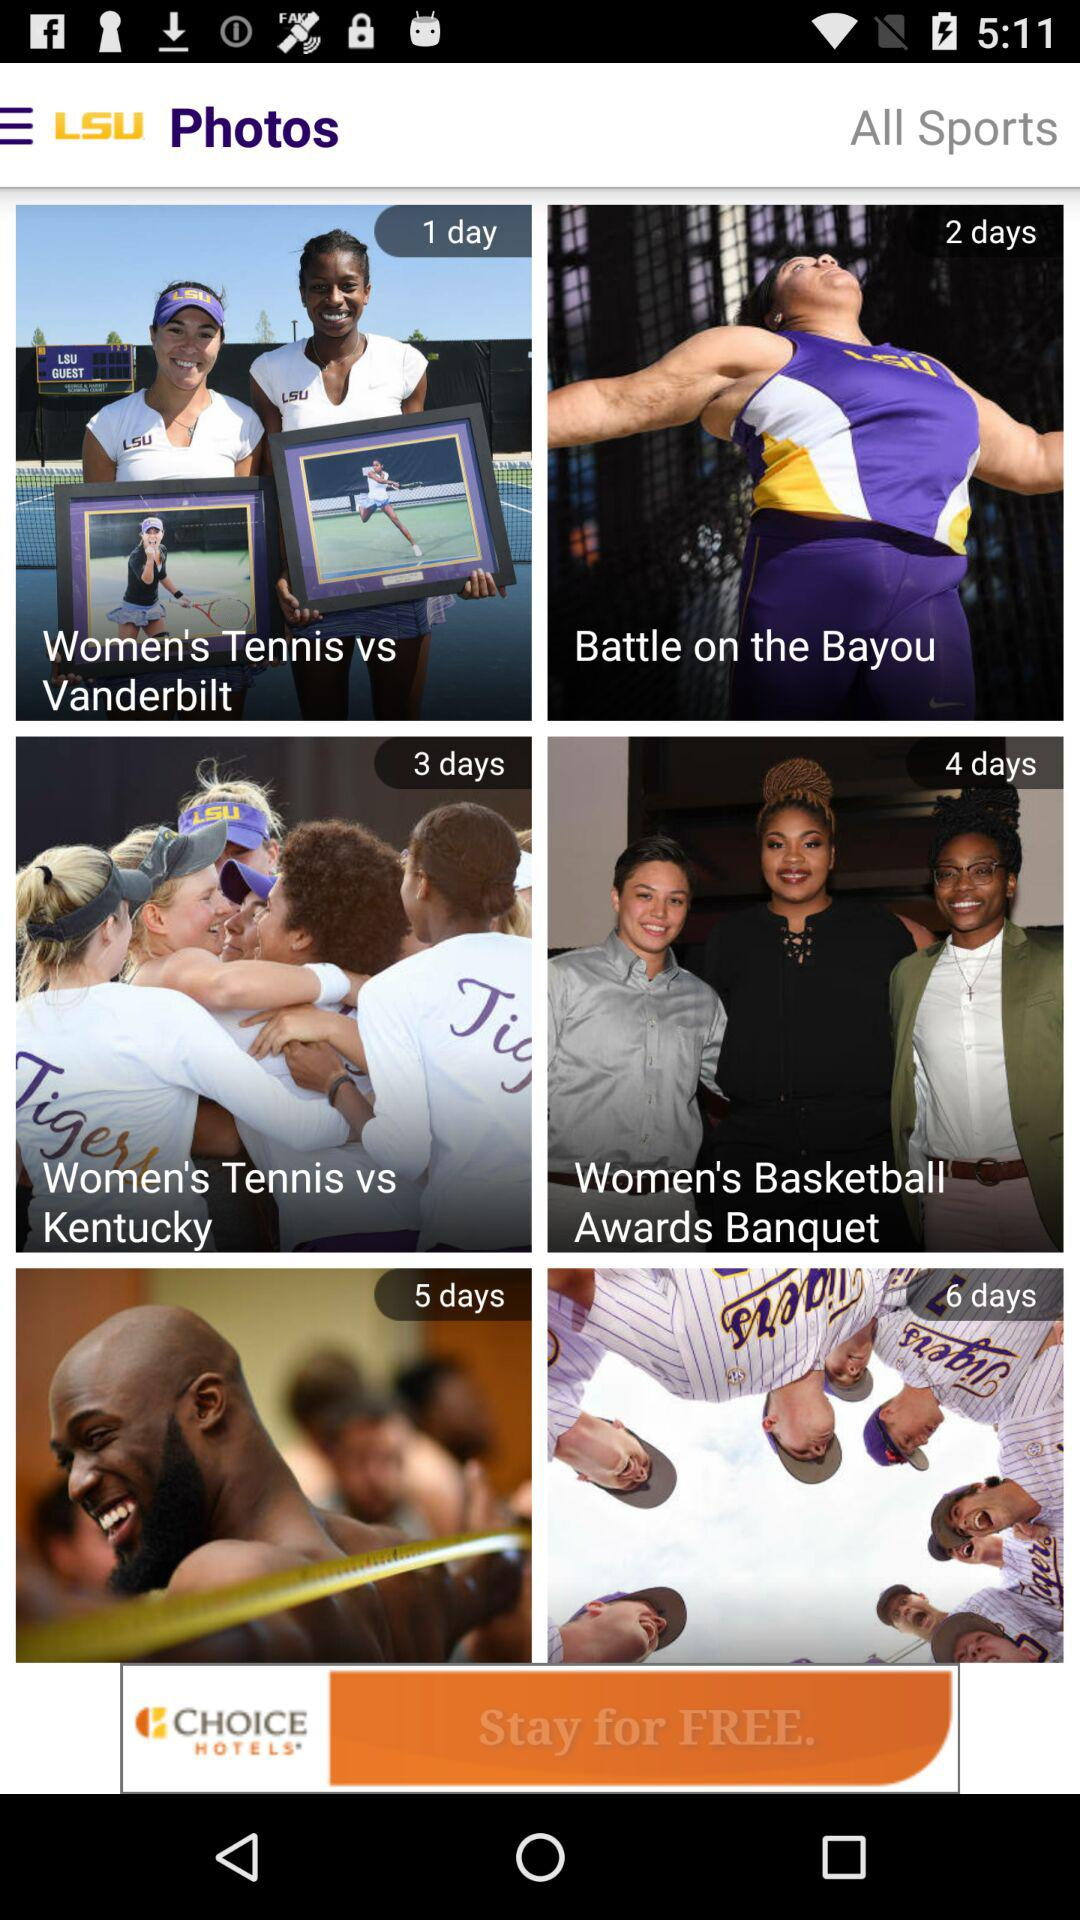How many days until the last event?
Answer the question using a single word or phrase. 6 days 